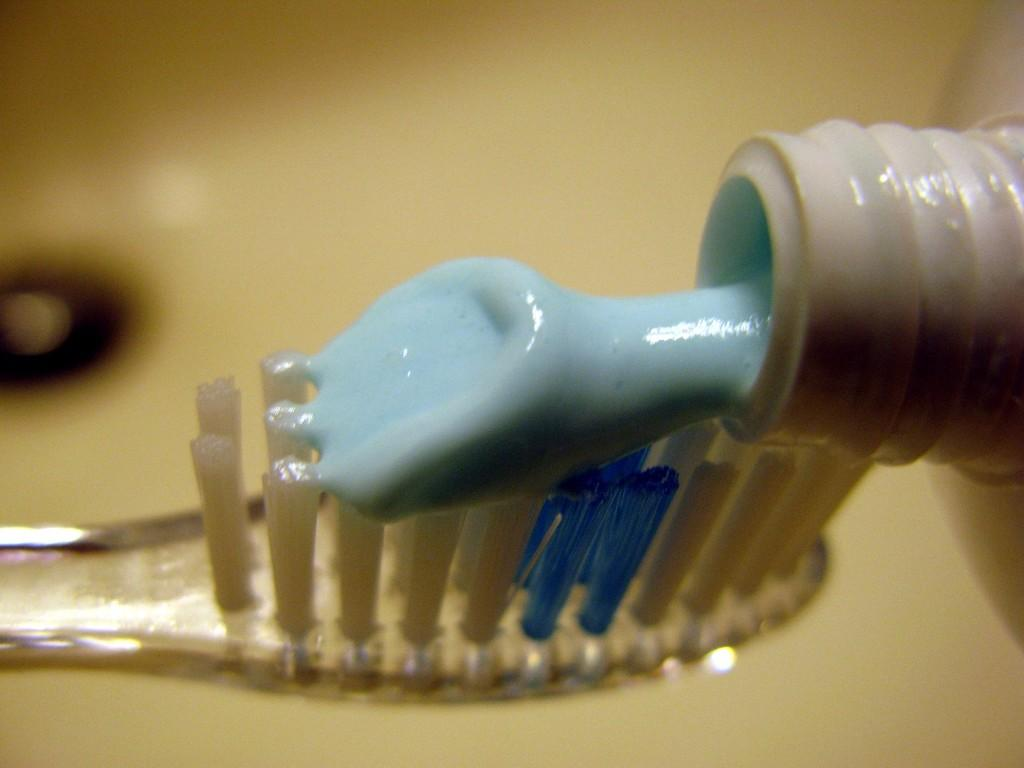What object is visible in the image? There is a toothbrush in the image. Can you describe the toothbrush? The toothbrush is transparent. What is on the toothbrush? There is blue-colored paste on the toothbrush. What color is the background of the image? The background of the image is cream-colored. What type of branch can be seen growing in the image? There is no branch present in the image; it features a toothbrush with blue-colored paste. How does the toothbrush care for the grass in the image? The toothbrush does not care for grass in the image, as it is a personal hygiene item meant for cleaning teeth. 